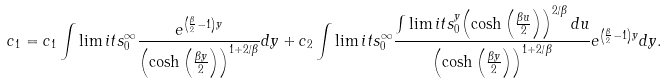Convert formula to latex. <formula><loc_0><loc_0><loc_500><loc_500>c _ { 1 } = c _ { 1 } \int \lim i t s _ { 0 } ^ { \infty } \frac { e ^ { \left ( \frac { \beta } { 2 } - 1 \right ) y } } { \left ( \cosh \left ( \frac { \beta y } { 2 } \right ) \right ) ^ { 1 + 2 / \beta } } d y + c _ { 2 } \int \lim i t s _ { 0 } ^ { \infty } \frac { \int \lim i t s _ { 0 } ^ { y } { \left ( \cosh \left ( \frac { \beta u } { 2 } \right ) \right ) ^ { 2 / \beta } d u } } { \left ( \cosh \left ( \frac { \beta y } { 2 } \right ) \right ) ^ { 1 + 2 / \beta } } e ^ { \left ( \frac { \beta } { 2 } - 1 \right ) y } d y .</formula> 